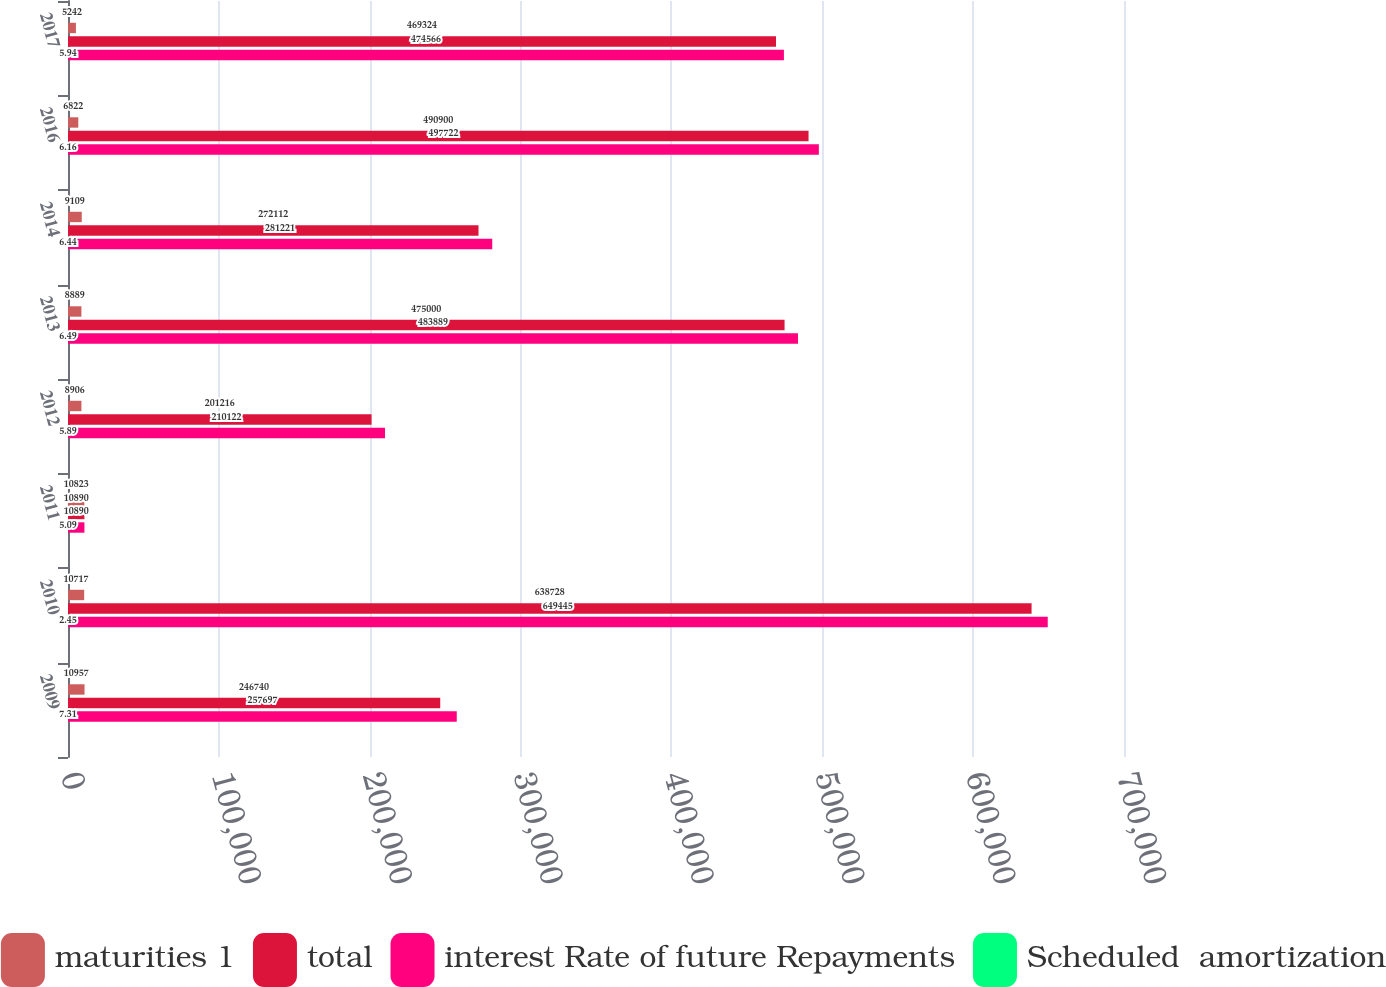Convert chart to OTSL. <chart><loc_0><loc_0><loc_500><loc_500><stacked_bar_chart><ecel><fcel>2009<fcel>2010<fcel>2011<fcel>2012<fcel>2013<fcel>2014<fcel>2016<fcel>2017<nl><fcel>maturities 1<fcel>10957<fcel>10717<fcel>10823<fcel>8906<fcel>8889<fcel>9109<fcel>6822<fcel>5242<nl><fcel>total<fcel>246740<fcel>638728<fcel>10890<fcel>201216<fcel>475000<fcel>272112<fcel>490900<fcel>469324<nl><fcel>interest Rate of future Repayments<fcel>257697<fcel>649445<fcel>10890<fcel>210122<fcel>483889<fcel>281221<fcel>497722<fcel>474566<nl><fcel>Scheduled  amortization<fcel>7.31<fcel>2.45<fcel>5.09<fcel>5.89<fcel>6.49<fcel>6.44<fcel>6.16<fcel>5.94<nl></chart> 